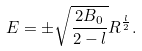<formula> <loc_0><loc_0><loc_500><loc_500>E = \pm \sqrt { \frac { 2 B _ { 0 } } { 2 - l } } R ^ { \frac { l } { 2 } } .</formula> 